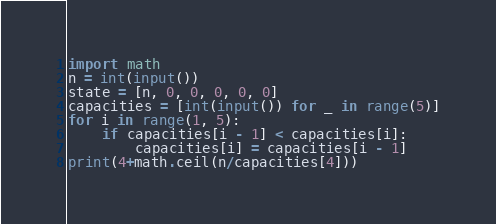<code> <loc_0><loc_0><loc_500><loc_500><_Python_>import math
n = int(input())
state = [n, 0, 0, 0, 0, 0]
capacities = [int(input()) for _ in range(5)]
for i in range(1, 5):
    if capacities[i - 1] < capacities[i]:
        capacities[i] = capacities[i - 1]
print(4+math.ceil(n/capacities[4]))
</code> 